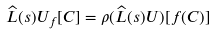<formula> <loc_0><loc_0><loc_500><loc_500>\widehat { L } ( s ) U _ { f } [ C ] = \rho ( \widehat { L } ( s ) U ) [ f ( C ) ]</formula> 